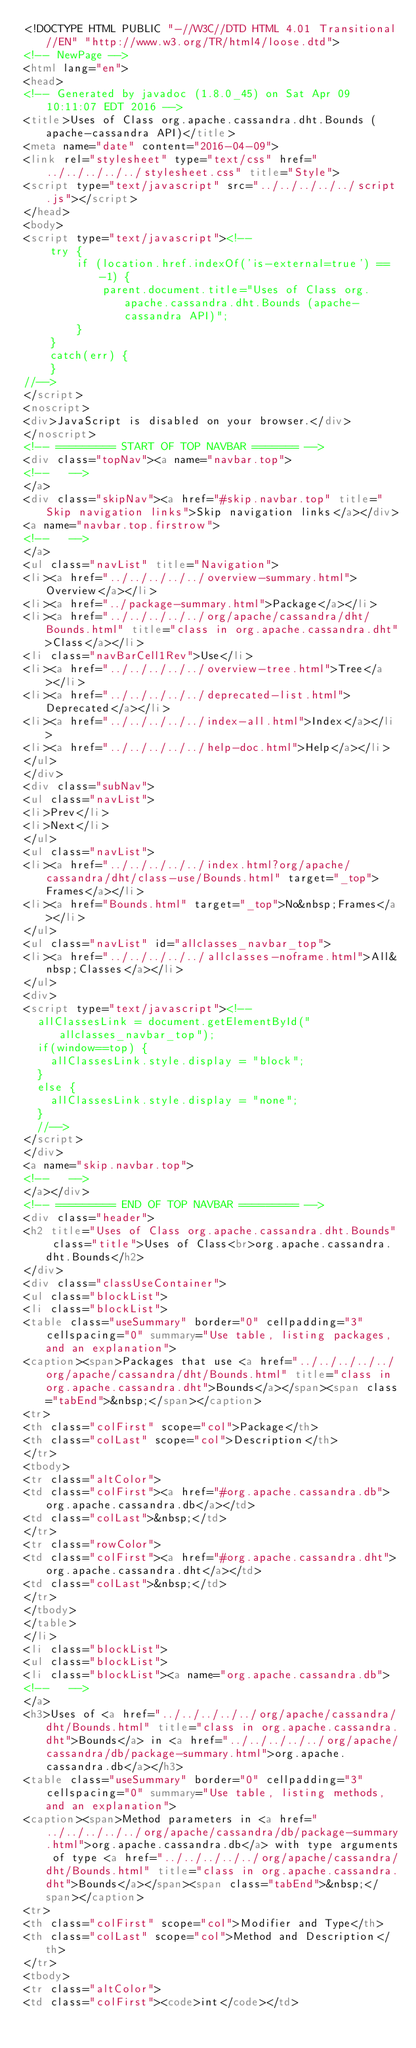<code> <loc_0><loc_0><loc_500><loc_500><_HTML_><!DOCTYPE HTML PUBLIC "-//W3C//DTD HTML 4.01 Transitional//EN" "http://www.w3.org/TR/html4/loose.dtd">
<!-- NewPage -->
<html lang="en">
<head>
<!-- Generated by javadoc (1.8.0_45) on Sat Apr 09 10:11:07 EDT 2016 -->
<title>Uses of Class org.apache.cassandra.dht.Bounds (apache-cassandra API)</title>
<meta name="date" content="2016-04-09">
<link rel="stylesheet" type="text/css" href="../../../../../stylesheet.css" title="Style">
<script type="text/javascript" src="../../../../../script.js"></script>
</head>
<body>
<script type="text/javascript"><!--
    try {
        if (location.href.indexOf('is-external=true') == -1) {
            parent.document.title="Uses of Class org.apache.cassandra.dht.Bounds (apache-cassandra API)";
        }
    }
    catch(err) {
    }
//-->
</script>
<noscript>
<div>JavaScript is disabled on your browser.</div>
</noscript>
<!-- ========= START OF TOP NAVBAR ======= -->
<div class="topNav"><a name="navbar.top">
<!--   -->
</a>
<div class="skipNav"><a href="#skip.navbar.top" title="Skip navigation links">Skip navigation links</a></div>
<a name="navbar.top.firstrow">
<!--   -->
</a>
<ul class="navList" title="Navigation">
<li><a href="../../../../../overview-summary.html">Overview</a></li>
<li><a href="../package-summary.html">Package</a></li>
<li><a href="../../../../../org/apache/cassandra/dht/Bounds.html" title="class in org.apache.cassandra.dht">Class</a></li>
<li class="navBarCell1Rev">Use</li>
<li><a href="../../../../../overview-tree.html">Tree</a></li>
<li><a href="../../../../../deprecated-list.html">Deprecated</a></li>
<li><a href="../../../../../index-all.html">Index</a></li>
<li><a href="../../../../../help-doc.html">Help</a></li>
</ul>
</div>
<div class="subNav">
<ul class="navList">
<li>Prev</li>
<li>Next</li>
</ul>
<ul class="navList">
<li><a href="../../../../../index.html?org/apache/cassandra/dht/class-use/Bounds.html" target="_top">Frames</a></li>
<li><a href="Bounds.html" target="_top">No&nbsp;Frames</a></li>
</ul>
<ul class="navList" id="allclasses_navbar_top">
<li><a href="../../../../../allclasses-noframe.html">All&nbsp;Classes</a></li>
</ul>
<div>
<script type="text/javascript"><!--
  allClassesLink = document.getElementById("allclasses_navbar_top");
  if(window==top) {
    allClassesLink.style.display = "block";
  }
  else {
    allClassesLink.style.display = "none";
  }
  //-->
</script>
</div>
<a name="skip.navbar.top">
<!--   -->
</a></div>
<!-- ========= END OF TOP NAVBAR ========= -->
<div class="header">
<h2 title="Uses of Class org.apache.cassandra.dht.Bounds" class="title">Uses of Class<br>org.apache.cassandra.dht.Bounds</h2>
</div>
<div class="classUseContainer">
<ul class="blockList">
<li class="blockList">
<table class="useSummary" border="0" cellpadding="3" cellspacing="0" summary="Use table, listing packages, and an explanation">
<caption><span>Packages that use <a href="../../../../../org/apache/cassandra/dht/Bounds.html" title="class in org.apache.cassandra.dht">Bounds</a></span><span class="tabEnd">&nbsp;</span></caption>
<tr>
<th class="colFirst" scope="col">Package</th>
<th class="colLast" scope="col">Description</th>
</tr>
<tbody>
<tr class="altColor">
<td class="colFirst"><a href="#org.apache.cassandra.db">org.apache.cassandra.db</a></td>
<td class="colLast">&nbsp;</td>
</tr>
<tr class="rowColor">
<td class="colFirst"><a href="#org.apache.cassandra.dht">org.apache.cassandra.dht</a></td>
<td class="colLast">&nbsp;</td>
</tr>
</tbody>
</table>
</li>
<li class="blockList">
<ul class="blockList">
<li class="blockList"><a name="org.apache.cassandra.db">
<!--   -->
</a>
<h3>Uses of <a href="../../../../../org/apache/cassandra/dht/Bounds.html" title="class in org.apache.cassandra.dht">Bounds</a> in <a href="../../../../../org/apache/cassandra/db/package-summary.html">org.apache.cassandra.db</a></h3>
<table class="useSummary" border="0" cellpadding="3" cellspacing="0" summary="Use table, listing methods, and an explanation">
<caption><span>Method parameters in <a href="../../../../../org/apache/cassandra/db/package-summary.html">org.apache.cassandra.db</a> with type arguments of type <a href="../../../../../org/apache/cassandra/dht/Bounds.html" title="class in org.apache.cassandra.dht">Bounds</a></span><span class="tabEnd">&nbsp;</span></caption>
<tr>
<th class="colFirst" scope="col">Modifier and Type</th>
<th class="colLast" scope="col">Method and Description</th>
</tr>
<tbody>
<tr class="altColor">
<td class="colFirst"><code>int</code></td></code> 